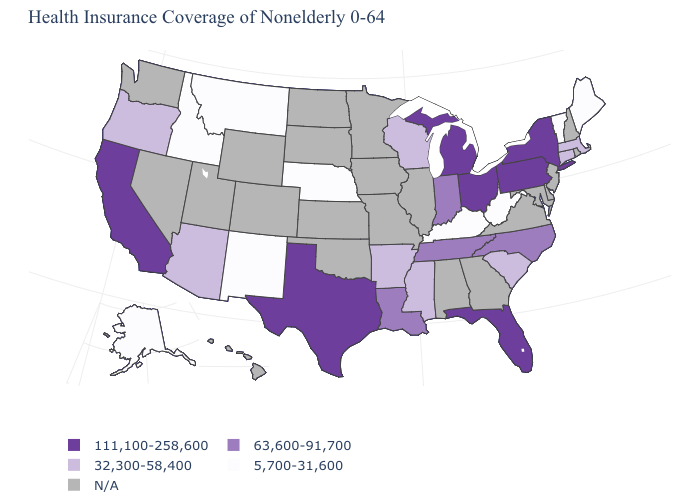What is the value of Delaware?
Be succinct. N/A. Does the map have missing data?
Be succinct. Yes. What is the value of Arizona?
Short answer required. 32,300-58,400. What is the value of Montana?
Be succinct. 5,700-31,600. Is the legend a continuous bar?
Keep it brief. No. Which states have the highest value in the USA?
Be succinct. California, Florida, Michigan, New York, Ohio, Pennsylvania, Texas. Among the states that border Iowa , which have the highest value?
Be succinct. Wisconsin. Which states have the lowest value in the USA?
Write a very short answer. Alaska, Idaho, Kentucky, Maine, Montana, Nebraska, New Mexico, Vermont, West Virginia. What is the value of Pennsylvania?
Concise answer only. 111,100-258,600. What is the value of Alaska?
Write a very short answer. 5,700-31,600. What is the value of North Dakota?
Short answer required. N/A. 